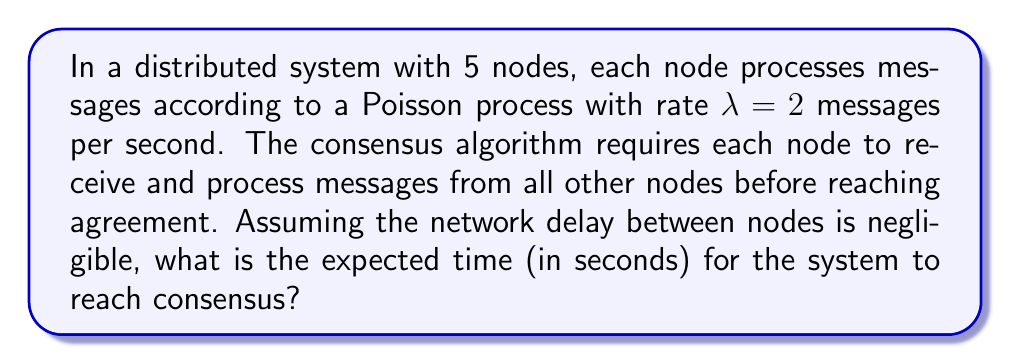Provide a solution to this math problem. To solve this problem, we'll use concepts from queuing theory and the properties of Poisson processes. Let's break it down step-by-step:

1) In a system with 5 nodes, each node needs to receive messages from 4 other nodes.

2) The time for a single node to receive a message from another node follows an exponential distribution with rate $\lambda = 2$ (since the Poisson process has rate 2).

3) The expected time for a single message to be received is $\frac{1}{\lambda} = \frac{1}{2}$ seconds.

4) For a node to receive messages from all 4 other nodes, we need to consider the maximum of 4 independent exponential distributions.

5) The expected value of the maximum of $n$ independent exponential random variables, each with rate $\lambda$, is given by the harmonic series:

   $$E[\max(X_1, ..., X_n)] = \frac{1}{\lambda} \sum_{i=1}^n \frac{1}{i}$$

6) In our case, $n = 4$ and $\lambda = 2$, so:

   $$E[\text{time for one node}] = \frac{1}{2} (1 + \frac{1}{2} + \frac{1}{3} + \frac{1}{4})$$

7) The system reaches consensus when all 5 nodes have received messages from all others. This is equivalent to taking the maximum of 5 independent random variables, each representing the time for one node to receive all messages.

8) We can apply the same formula again, but now with $n = 5$ and $\lambda = \frac{2}{1 + \frac{1}{2} + \frac{1}{3} + \frac{1}{4}}$:

   $$E[\text{consensus time}] = \frac{1 + \frac{1}{2} + \frac{1}{3} + \frac{1}{4}}{2} (1 + \frac{1}{2} + \frac{1}{3} + \frac{1}{4} + \frac{1}{5})$$

9) Calculating this:

   $$E[\text{consensus time}] = \frac{25}{24} \cdot \frac{137}{60} \approx 1.4271 \text{ seconds}$$
Answer: $\frac{137}{120} \approx 1.4271$ seconds 